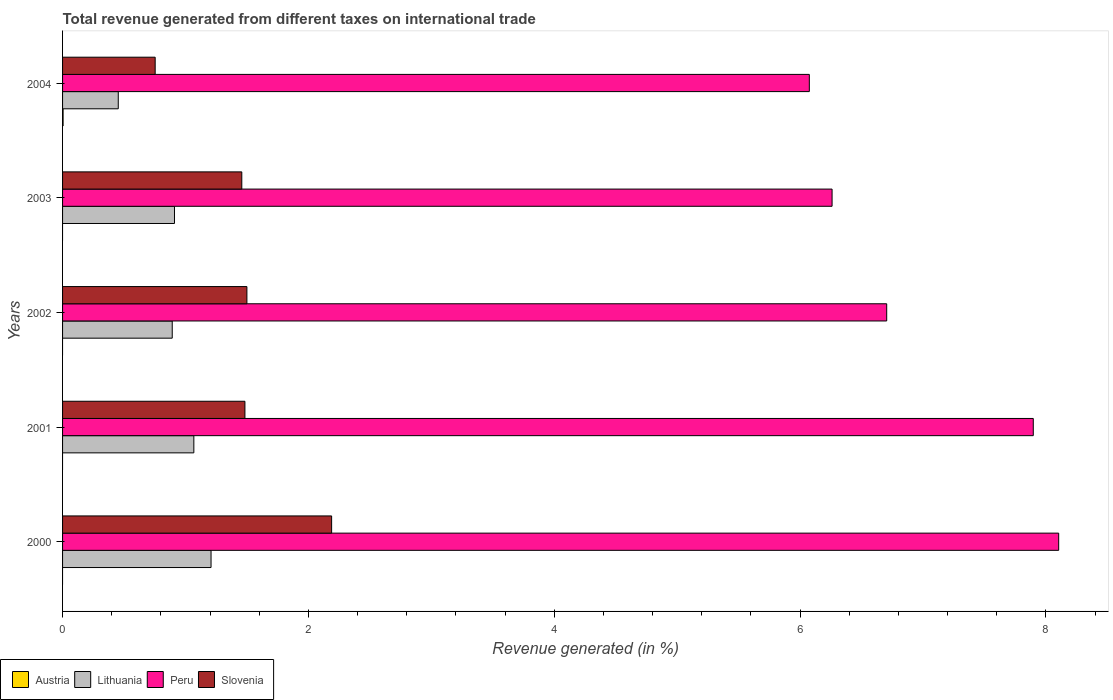How many bars are there on the 1st tick from the top?
Provide a succinct answer. 4. How many bars are there on the 4th tick from the bottom?
Keep it short and to the point. 3. What is the label of the 3rd group of bars from the top?
Provide a succinct answer. 2002. In how many cases, is the number of bars for a given year not equal to the number of legend labels?
Provide a succinct answer. 4. What is the total revenue generated in Peru in 2002?
Keep it short and to the point. 6.7. Across all years, what is the maximum total revenue generated in Peru?
Keep it short and to the point. 8.1. Across all years, what is the minimum total revenue generated in Lithuania?
Your response must be concise. 0.45. In which year was the total revenue generated in Austria maximum?
Your response must be concise. 2004. What is the total total revenue generated in Peru in the graph?
Provide a succinct answer. 35.04. What is the difference between the total revenue generated in Lithuania in 2000 and that in 2003?
Keep it short and to the point. 0.3. What is the difference between the total revenue generated in Lithuania in 2000 and the total revenue generated in Peru in 2002?
Give a very brief answer. -5.5. What is the average total revenue generated in Austria per year?
Make the answer very short. 0. In the year 2004, what is the difference between the total revenue generated in Peru and total revenue generated in Austria?
Offer a terse response. 6.07. In how many years, is the total revenue generated in Peru greater than 4.4 %?
Keep it short and to the point. 5. What is the ratio of the total revenue generated in Lithuania in 2000 to that in 2004?
Keep it short and to the point. 2.67. Is the total revenue generated in Peru in 2000 less than that in 2003?
Keep it short and to the point. No. What is the difference between the highest and the second highest total revenue generated in Lithuania?
Provide a succinct answer. 0.14. What is the difference between the highest and the lowest total revenue generated in Peru?
Keep it short and to the point. 2.03. In how many years, is the total revenue generated in Peru greater than the average total revenue generated in Peru taken over all years?
Offer a terse response. 2. Is the sum of the total revenue generated in Peru in 2002 and 2004 greater than the maximum total revenue generated in Austria across all years?
Your answer should be compact. Yes. Is it the case that in every year, the sum of the total revenue generated in Slovenia and total revenue generated in Peru is greater than the sum of total revenue generated in Austria and total revenue generated in Lithuania?
Offer a terse response. Yes. How many bars are there?
Offer a very short reply. 16. What is the difference between two consecutive major ticks on the X-axis?
Your answer should be compact. 2. Are the values on the major ticks of X-axis written in scientific E-notation?
Offer a terse response. No. Does the graph contain grids?
Make the answer very short. No. How are the legend labels stacked?
Offer a very short reply. Horizontal. What is the title of the graph?
Keep it short and to the point. Total revenue generated from different taxes on international trade. What is the label or title of the X-axis?
Offer a very short reply. Revenue generated (in %). What is the Revenue generated (in %) in Lithuania in 2000?
Provide a short and direct response. 1.21. What is the Revenue generated (in %) of Peru in 2000?
Make the answer very short. 8.1. What is the Revenue generated (in %) in Slovenia in 2000?
Offer a terse response. 2.19. What is the Revenue generated (in %) of Austria in 2001?
Offer a very short reply. 0. What is the Revenue generated (in %) in Lithuania in 2001?
Your response must be concise. 1.07. What is the Revenue generated (in %) in Peru in 2001?
Offer a very short reply. 7.9. What is the Revenue generated (in %) of Slovenia in 2001?
Ensure brevity in your answer.  1.48. What is the Revenue generated (in %) of Austria in 2002?
Provide a short and direct response. 0. What is the Revenue generated (in %) of Lithuania in 2002?
Give a very brief answer. 0.89. What is the Revenue generated (in %) of Peru in 2002?
Provide a succinct answer. 6.7. What is the Revenue generated (in %) of Slovenia in 2002?
Keep it short and to the point. 1.5. What is the Revenue generated (in %) of Austria in 2003?
Offer a very short reply. 0. What is the Revenue generated (in %) in Lithuania in 2003?
Your answer should be very brief. 0.91. What is the Revenue generated (in %) in Peru in 2003?
Offer a terse response. 6.26. What is the Revenue generated (in %) of Slovenia in 2003?
Offer a very short reply. 1.46. What is the Revenue generated (in %) in Austria in 2004?
Provide a short and direct response. 0. What is the Revenue generated (in %) in Lithuania in 2004?
Offer a very short reply. 0.45. What is the Revenue generated (in %) of Peru in 2004?
Keep it short and to the point. 6.08. What is the Revenue generated (in %) of Slovenia in 2004?
Make the answer very short. 0.75. Across all years, what is the maximum Revenue generated (in %) of Austria?
Offer a terse response. 0. Across all years, what is the maximum Revenue generated (in %) of Lithuania?
Ensure brevity in your answer.  1.21. Across all years, what is the maximum Revenue generated (in %) of Peru?
Keep it short and to the point. 8.1. Across all years, what is the maximum Revenue generated (in %) of Slovenia?
Provide a short and direct response. 2.19. Across all years, what is the minimum Revenue generated (in %) in Lithuania?
Your answer should be compact. 0.45. Across all years, what is the minimum Revenue generated (in %) in Peru?
Offer a terse response. 6.08. Across all years, what is the minimum Revenue generated (in %) of Slovenia?
Give a very brief answer. 0.75. What is the total Revenue generated (in %) of Austria in the graph?
Your answer should be very brief. 0. What is the total Revenue generated (in %) in Lithuania in the graph?
Your answer should be compact. 4.53. What is the total Revenue generated (in %) in Peru in the graph?
Make the answer very short. 35.04. What is the total Revenue generated (in %) in Slovenia in the graph?
Your answer should be very brief. 7.38. What is the difference between the Revenue generated (in %) in Lithuania in 2000 and that in 2001?
Offer a terse response. 0.14. What is the difference between the Revenue generated (in %) of Peru in 2000 and that in 2001?
Your response must be concise. 0.21. What is the difference between the Revenue generated (in %) of Slovenia in 2000 and that in 2001?
Offer a terse response. 0.71. What is the difference between the Revenue generated (in %) of Lithuania in 2000 and that in 2002?
Provide a succinct answer. 0.32. What is the difference between the Revenue generated (in %) of Peru in 2000 and that in 2002?
Keep it short and to the point. 1.4. What is the difference between the Revenue generated (in %) in Slovenia in 2000 and that in 2002?
Give a very brief answer. 0.69. What is the difference between the Revenue generated (in %) in Lithuania in 2000 and that in 2003?
Ensure brevity in your answer.  0.3. What is the difference between the Revenue generated (in %) of Peru in 2000 and that in 2003?
Offer a very short reply. 1.84. What is the difference between the Revenue generated (in %) of Slovenia in 2000 and that in 2003?
Offer a very short reply. 0.73. What is the difference between the Revenue generated (in %) of Lithuania in 2000 and that in 2004?
Provide a succinct answer. 0.75. What is the difference between the Revenue generated (in %) of Peru in 2000 and that in 2004?
Offer a very short reply. 2.03. What is the difference between the Revenue generated (in %) of Slovenia in 2000 and that in 2004?
Offer a very short reply. 1.44. What is the difference between the Revenue generated (in %) in Lithuania in 2001 and that in 2002?
Make the answer very short. 0.18. What is the difference between the Revenue generated (in %) of Peru in 2001 and that in 2002?
Your answer should be compact. 1.19. What is the difference between the Revenue generated (in %) of Slovenia in 2001 and that in 2002?
Provide a succinct answer. -0.02. What is the difference between the Revenue generated (in %) of Lithuania in 2001 and that in 2003?
Give a very brief answer. 0.16. What is the difference between the Revenue generated (in %) of Peru in 2001 and that in 2003?
Your answer should be very brief. 1.64. What is the difference between the Revenue generated (in %) of Slovenia in 2001 and that in 2003?
Keep it short and to the point. 0.03. What is the difference between the Revenue generated (in %) in Lithuania in 2001 and that in 2004?
Offer a very short reply. 0.61. What is the difference between the Revenue generated (in %) in Peru in 2001 and that in 2004?
Ensure brevity in your answer.  1.82. What is the difference between the Revenue generated (in %) in Slovenia in 2001 and that in 2004?
Your answer should be very brief. 0.73. What is the difference between the Revenue generated (in %) in Lithuania in 2002 and that in 2003?
Your response must be concise. -0.02. What is the difference between the Revenue generated (in %) in Peru in 2002 and that in 2003?
Keep it short and to the point. 0.44. What is the difference between the Revenue generated (in %) in Slovenia in 2002 and that in 2003?
Ensure brevity in your answer.  0.04. What is the difference between the Revenue generated (in %) in Lithuania in 2002 and that in 2004?
Your answer should be compact. 0.44. What is the difference between the Revenue generated (in %) of Peru in 2002 and that in 2004?
Provide a succinct answer. 0.63. What is the difference between the Revenue generated (in %) of Slovenia in 2002 and that in 2004?
Give a very brief answer. 0.75. What is the difference between the Revenue generated (in %) in Lithuania in 2003 and that in 2004?
Keep it short and to the point. 0.46. What is the difference between the Revenue generated (in %) of Peru in 2003 and that in 2004?
Ensure brevity in your answer.  0.19. What is the difference between the Revenue generated (in %) of Slovenia in 2003 and that in 2004?
Offer a very short reply. 0.7. What is the difference between the Revenue generated (in %) in Lithuania in 2000 and the Revenue generated (in %) in Peru in 2001?
Offer a very short reply. -6.69. What is the difference between the Revenue generated (in %) in Lithuania in 2000 and the Revenue generated (in %) in Slovenia in 2001?
Give a very brief answer. -0.28. What is the difference between the Revenue generated (in %) in Peru in 2000 and the Revenue generated (in %) in Slovenia in 2001?
Your answer should be compact. 6.62. What is the difference between the Revenue generated (in %) of Lithuania in 2000 and the Revenue generated (in %) of Peru in 2002?
Ensure brevity in your answer.  -5.5. What is the difference between the Revenue generated (in %) in Lithuania in 2000 and the Revenue generated (in %) in Slovenia in 2002?
Give a very brief answer. -0.29. What is the difference between the Revenue generated (in %) of Peru in 2000 and the Revenue generated (in %) of Slovenia in 2002?
Offer a terse response. 6.6. What is the difference between the Revenue generated (in %) in Lithuania in 2000 and the Revenue generated (in %) in Peru in 2003?
Offer a terse response. -5.05. What is the difference between the Revenue generated (in %) of Lithuania in 2000 and the Revenue generated (in %) of Slovenia in 2003?
Your answer should be very brief. -0.25. What is the difference between the Revenue generated (in %) in Peru in 2000 and the Revenue generated (in %) in Slovenia in 2003?
Your answer should be compact. 6.65. What is the difference between the Revenue generated (in %) of Lithuania in 2000 and the Revenue generated (in %) of Peru in 2004?
Provide a short and direct response. -4.87. What is the difference between the Revenue generated (in %) of Lithuania in 2000 and the Revenue generated (in %) of Slovenia in 2004?
Your answer should be compact. 0.45. What is the difference between the Revenue generated (in %) of Peru in 2000 and the Revenue generated (in %) of Slovenia in 2004?
Ensure brevity in your answer.  7.35. What is the difference between the Revenue generated (in %) of Lithuania in 2001 and the Revenue generated (in %) of Peru in 2002?
Provide a short and direct response. -5.64. What is the difference between the Revenue generated (in %) of Lithuania in 2001 and the Revenue generated (in %) of Slovenia in 2002?
Your answer should be very brief. -0.43. What is the difference between the Revenue generated (in %) in Peru in 2001 and the Revenue generated (in %) in Slovenia in 2002?
Your answer should be very brief. 6.4. What is the difference between the Revenue generated (in %) of Lithuania in 2001 and the Revenue generated (in %) of Peru in 2003?
Your answer should be compact. -5.19. What is the difference between the Revenue generated (in %) of Lithuania in 2001 and the Revenue generated (in %) of Slovenia in 2003?
Your response must be concise. -0.39. What is the difference between the Revenue generated (in %) in Peru in 2001 and the Revenue generated (in %) in Slovenia in 2003?
Offer a terse response. 6.44. What is the difference between the Revenue generated (in %) in Lithuania in 2001 and the Revenue generated (in %) in Peru in 2004?
Your response must be concise. -5.01. What is the difference between the Revenue generated (in %) of Lithuania in 2001 and the Revenue generated (in %) of Slovenia in 2004?
Offer a terse response. 0.31. What is the difference between the Revenue generated (in %) in Peru in 2001 and the Revenue generated (in %) in Slovenia in 2004?
Ensure brevity in your answer.  7.14. What is the difference between the Revenue generated (in %) of Lithuania in 2002 and the Revenue generated (in %) of Peru in 2003?
Give a very brief answer. -5.37. What is the difference between the Revenue generated (in %) of Lithuania in 2002 and the Revenue generated (in %) of Slovenia in 2003?
Your answer should be compact. -0.57. What is the difference between the Revenue generated (in %) in Peru in 2002 and the Revenue generated (in %) in Slovenia in 2003?
Offer a terse response. 5.25. What is the difference between the Revenue generated (in %) of Lithuania in 2002 and the Revenue generated (in %) of Peru in 2004?
Make the answer very short. -5.18. What is the difference between the Revenue generated (in %) of Lithuania in 2002 and the Revenue generated (in %) of Slovenia in 2004?
Offer a very short reply. 0.14. What is the difference between the Revenue generated (in %) in Peru in 2002 and the Revenue generated (in %) in Slovenia in 2004?
Give a very brief answer. 5.95. What is the difference between the Revenue generated (in %) in Lithuania in 2003 and the Revenue generated (in %) in Peru in 2004?
Your answer should be compact. -5.16. What is the difference between the Revenue generated (in %) in Lithuania in 2003 and the Revenue generated (in %) in Slovenia in 2004?
Your answer should be very brief. 0.16. What is the difference between the Revenue generated (in %) of Peru in 2003 and the Revenue generated (in %) of Slovenia in 2004?
Your answer should be very brief. 5.51. What is the average Revenue generated (in %) of Austria per year?
Keep it short and to the point. 0. What is the average Revenue generated (in %) in Lithuania per year?
Your answer should be very brief. 0.91. What is the average Revenue generated (in %) in Peru per year?
Keep it short and to the point. 7.01. What is the average Revenue generated (in %) in Slovenia per year?
Keep it short and to the point. 1.48. In the year 2000, what is the difference between the Revenue generated (in %) in Lithuania and Revenue generated (in %) in Peru?
Your response must be concise. -6.9. In the year 2000, what is the difference between the Revenue generated (in %) of Lithuania and Revenue generated (in %) of Slovenia?
Ensure brevity in your answer.  -0.98. In the year 2000, what is the difference between the Revenue generated (in %) in Peru and Revenue generated (in %) in Slovenia?
Your answer should be compact. 5.91. In the year 2001, what is the difference between the Revenue generated (in %) in Lithuania and Revenue generated (in %) in Peru?
Ensure brevity in your answer.  -6.83. In the year 2001, what is the difference between the Revenue generated (in %) of Lithuania and Revenue generated (in %) of Slovenia?
Your response must be concise. -0.42. In the year 2001, what is the difference between the Revenue generated (in %) of Peru and Revenue generated (in %) of Slovenia?
Your answer should be very brief. 6.41. In the year 2002, what is the difference between the Revenue generated (in %) in Lithuania and Revenue generated (in %) in Peru?
Provide a short and direct response. -5.81. In the year 2002, what is the difference between the Revenue generated (in %) of Lithuania and Revenue generated (in %) of Slovenia?
Make the answer very short. -0.61. In the year 2002, what is the difference between the Revenue generated (in %) of Peru and Revenue generated (in %) of Slovenia?
Offer a terse response. 5.2. In the year 2003, what is the difference between the Revenue generated (in %) of Lithuania and Revenue generated (in %) of Peru?
Offer a terse response. -5.35. In the year 2003, what is the difference between the Revenue generated (in %) in Lithuania and Revenue generated (in %) in Slovenia?
Keep it short and to the point. -0.55. In the year 2003, what is the difference between the Revenue generated (in %) in Peru and Revenue generated (in %) in Slovenia?
Provide a short and direct response. 4.8. In the year 2004, what is the difference between the Revenue generated (in %) in Austria and Revenue generated (in %) in Lithuania?
Give a very brief answer. -0.45. In the year 2004, what is the difference between the Revenue generated (in %) in Austria and Revenue generated (in %) in Peru?
Your response must be concise. -6.07. In the year 2004, what is the difference between the Revenue generated (in %) of Austria and Revenue generated (in %) of Slovenia?
Offer a terse response. -0.75. In the year 2004, what is the difference between the Revenue generated (in %) of Lithuania and Revenue generated (in %) of Peru?
Offer a very short reply. -5.62. In the year 2004, what is the difference between the Revenue generated (in %) in Lithuania and Revenue generated (in %) in Slovenia?
Your response must be concise. -0.3. In the year 2004, what is the difference between the Revenue generated (in %) in Peru and Revenue generated (in %) in Slovenia?
Your response must be concise. 5.32. What is the ratio of the Revenue generated (in %) of Lithuania in 2000 to that in 2001?
Your answer should be compact. 1.13. What is the ratio of the Revenue generated (in %) in Peru in 2000 to that in 2001?
Your answer should be very brief. 1.03. What is the ratio of the Revenue generated (in %) in Slovenia in 2000 to that in 2001?
Your answer should be compact. 1.48. What is the ratio of the Revenue generated (in %) in Lithuania in 2000 to that in 2002?
Ensure brevity in your answer.  1.35. What is the ratio of the Revenue generated (in %) of Peru in 2000 to that in 2002?
Offer a very short reply. 1.21. What is the ratio of the Revenue generated (in %) of Slovenia in 2000 to that in 2002?
Your answer should be very brief. 1.46. What is the ratio of the Revenue generated (in %) in Lithuania in 2000 to that in 2003?
Offer a very short reply. 1.33. What is the ratio of the Revenue generated (in %) of Peru in 2000 to that in 2003?
Offer a terse response. 1.29. What is the ratio of the Revenue generated (in %) of Slovenia in 2000 to that in 2003?
Make the answer very short. 1.5. What is the ratio of the Revenue generated (in %) of Lithuania in 2000 to that in 2004?
Provide a short and direct response. 2.67. What is the ratio of the Revenue generated (in %) in Peru in 2000 to that in 2004?
Provide a succinct answer. 1.33. What is the ratio of the Revenue generated (in %) in Slovenia in 2000 to that in 2004?
Your answer should be compact. 2.91. What is the ratio of the Revenue generated (in %) in Lithuania in 2001 to that in 2002?
Your answer should be very brief. 1.2. What is the ratio of the Revenue generated (in %) in Peru in 2001 to that in 2002?
Keep it short and to the point. 1.18. What is the ratio of the Revenue generated (in %) of Slovenia in 2001 to that in 2002?
Make the answer very short. 0.99. What is the ratio of the Revenue generated (in %) in Lithuania in 2001 to that in 2003?
Your answer should be very brief. 1.17. What is the ratio of the Revenue generated (in %) of Peru in 2001 to that in 2003?
Offer a very short reply. 1.26. What is the ratio of the Revenue generated (in %) of Slovenia in 2001 to that in 2003?
Ensure brevity in your answer.  1.02. What is the ratio of the Revenue generated (in %) in Lithuania in 2001 to that in 2004?
Keep it short and to the point. 2.36. What is the ratio of the Revenue generated (in %) in Peru in 2001 to that in 2004?
Ensure brevity in your answer.  1.3. What is the ratio of the Revenue generated (in %) in Slovenia in 2001 to that in 2004?
Keep it short and to the point. 1.97. What is the ratio of the Revenue generated (in %) of Lithuania in 2002 to that in 2003?
Offer a very short reply. 0.98. What is the ratio of the Revenue generated (in %) of Peru in 2002 to that in 2003?
Keep it short and to the point. 1.07. What is the ratio of the Revenue generated (in %) in Slovenia in 2002 to that in 2003?
Make the answer very short. 1.03. What is the ratio of the Revenue generated (in %) in Lithuania in 2002 to that in 2004?
Your answer should be very brief. 1.97. What is the ratio of the Revenue generated (in %) of Peru in 2002 to that in 2004?
Keep it short and to the point. 1.1. What is the ratio of the Revenue generated (in %) of Slovenia in 2002 to that in 2004?
Make the answer very short. 1.99. What is the ratio of the Revenue generated (in %) of Lithuania in 2003 to that in 2004?
Give a very brief answer. 2.01. What is the ratio of the Revenue generated (in %) of Peru in 2003 to that in 2004?
Give a very brief answer. 1.03. What is the ratio of the Revenue generated (in %) of Slovenia in 2003 to that in 2004?
Keep it short and to the point. 1.94. What is the difference between the highest and the second highest Revenue generated (in %) in Lithuania?
Offer a terse response. 0.14. What is the difference between the highest and the second highest Revenue generated (in %) in Peru?
Provide a short and direct response. 0.21. What is the difference between the highest and the second highest Revenue generated (in %) in Slovenia?
Your answer should be very brief. 0.69. What is the difference between the highest and the lowest Revenue generated (in %) in Austria?
Your answer should be very brief. 0. What is the difference between the highest and the lowest Revenue generated (in %) of Lithuania?
Make the answer very short. 0.75. What is the difference between the highest and the lowest Revenue generated (in %) in Peru?
Provide a short and direct response. 2.03. What is the difference between the highest and the lowest Revenue generated (in %) of Slovenia?
Give a very brief answer. 1.44. 